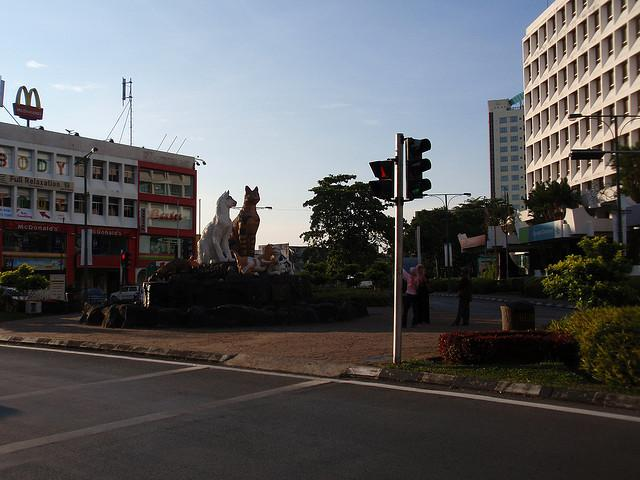What type of burger could be eaten here? big mac 